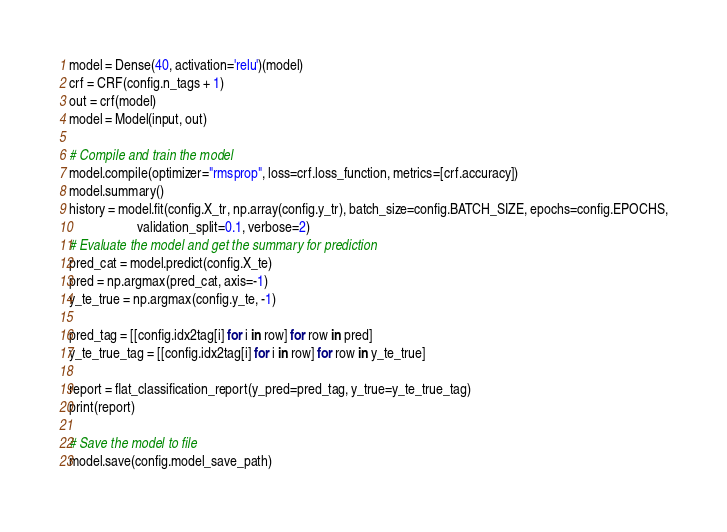Convert code to text. <code><loc_0><loc_0><loc_500><loc_500><_Python_>model = Dense(40, activation='relu')(model)
crf = CRF(config.n_tags + 1)
out = crf(model)
model = Model(input, out)

# Compile and train the model
model.compile(optimizer="rmsprop", loss=crf.loss_function, metrics=[crf.accuracy])
model.summary()
history = model.fit(config.X_tr, np.array(config.y_tr), batch_size=config.BATCH_SIZE, epochs=config.EPOCHS,
                    validation_split=0.1, verbose=2)
# Evaluate the model and get the summary for prediction
pred_cat = model.predict(config.X_te)
pred = np.argmax(pred_cat, axis=-1)
y_te_true = np.argmax(config.y_te, -1)

pred_tag = [[config.idx2tag[i] for i in row] for row in pred]
y_te_true_tag = [[config.idx2tag[i] for i in row] for row in y_te_true]

report = flat_classification_report(y_pred=pred_tag, y_true=y_te_true_tag)
print(report)

# Save the model to file
model.save(config.model_save_path)
</code> 